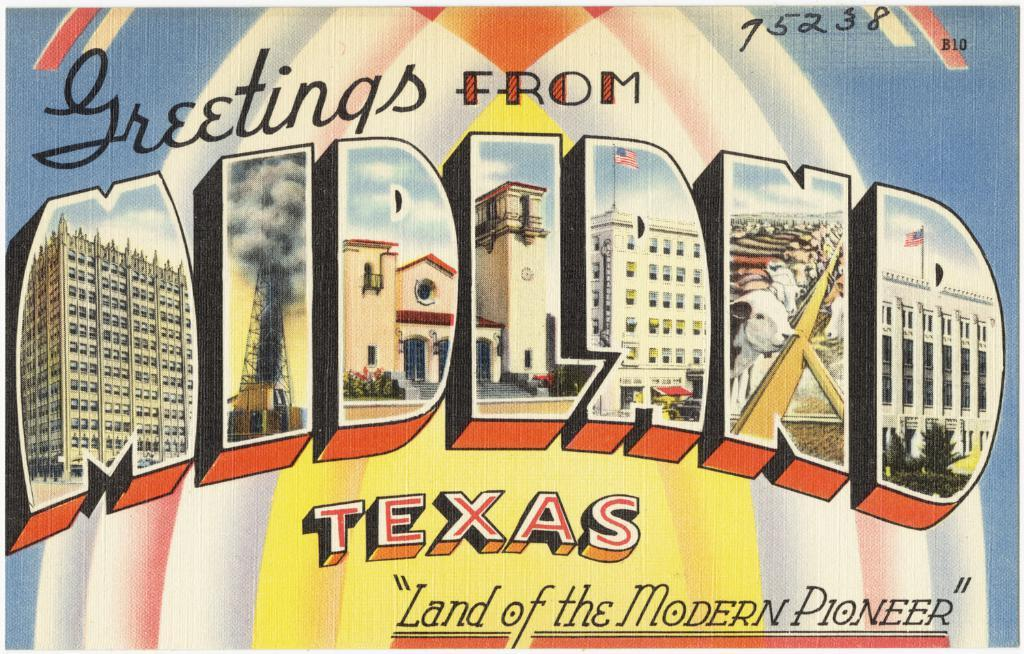Provide a one-sentence caption for the provided image. A postcard has the word Midland with pictures in side the letters on it. 